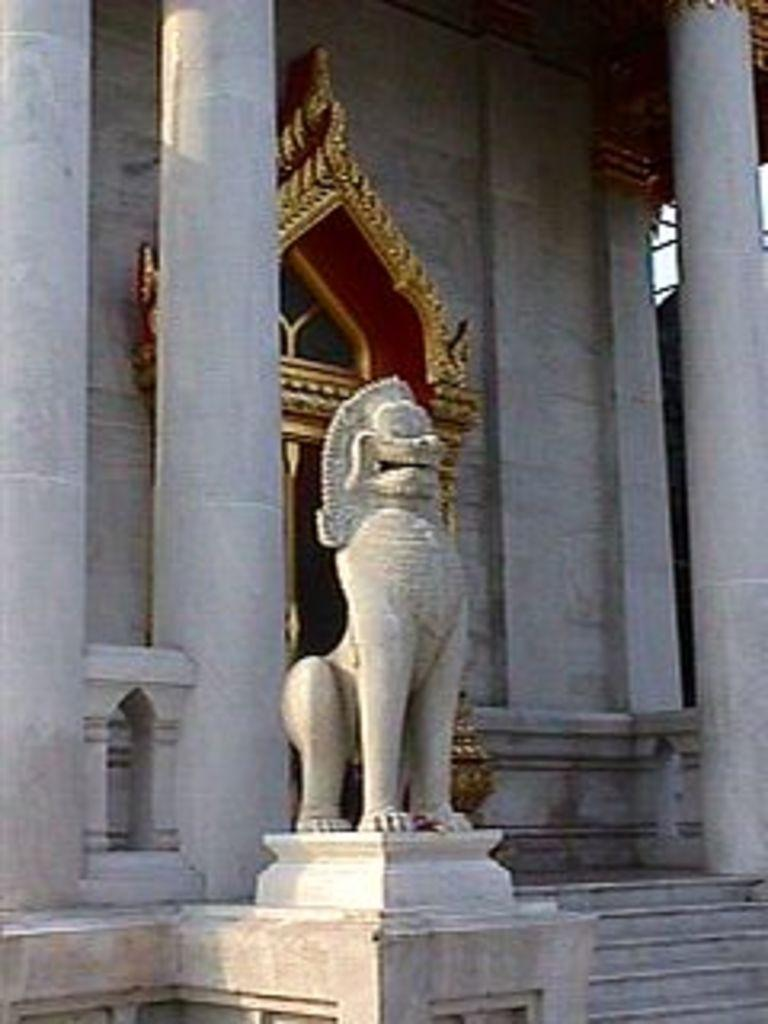What is the main subject of the image? There is a sculpture on a platform in the image. What architectural features can be seen in the image? There are steps, pillars, a wall, and a door in the image. Can you describe the platform on which the sculpture is placed? The sculpture is on a platform, but the specific details of the platform are not mentioned in the facts. What is the purpose of the steps in the image? The steps might be used for accessing the platform or the area around the sculpture, but their exact purpose is not mentioned in the facts. What type of chicken is sitting on the fork in the image? There is no fork or chicken present in the image. What color is the underwear worn by the sculpture in the image? The facts do not mention any underwear worn by the sculpture, and sculptures typically do not wear clothing. 